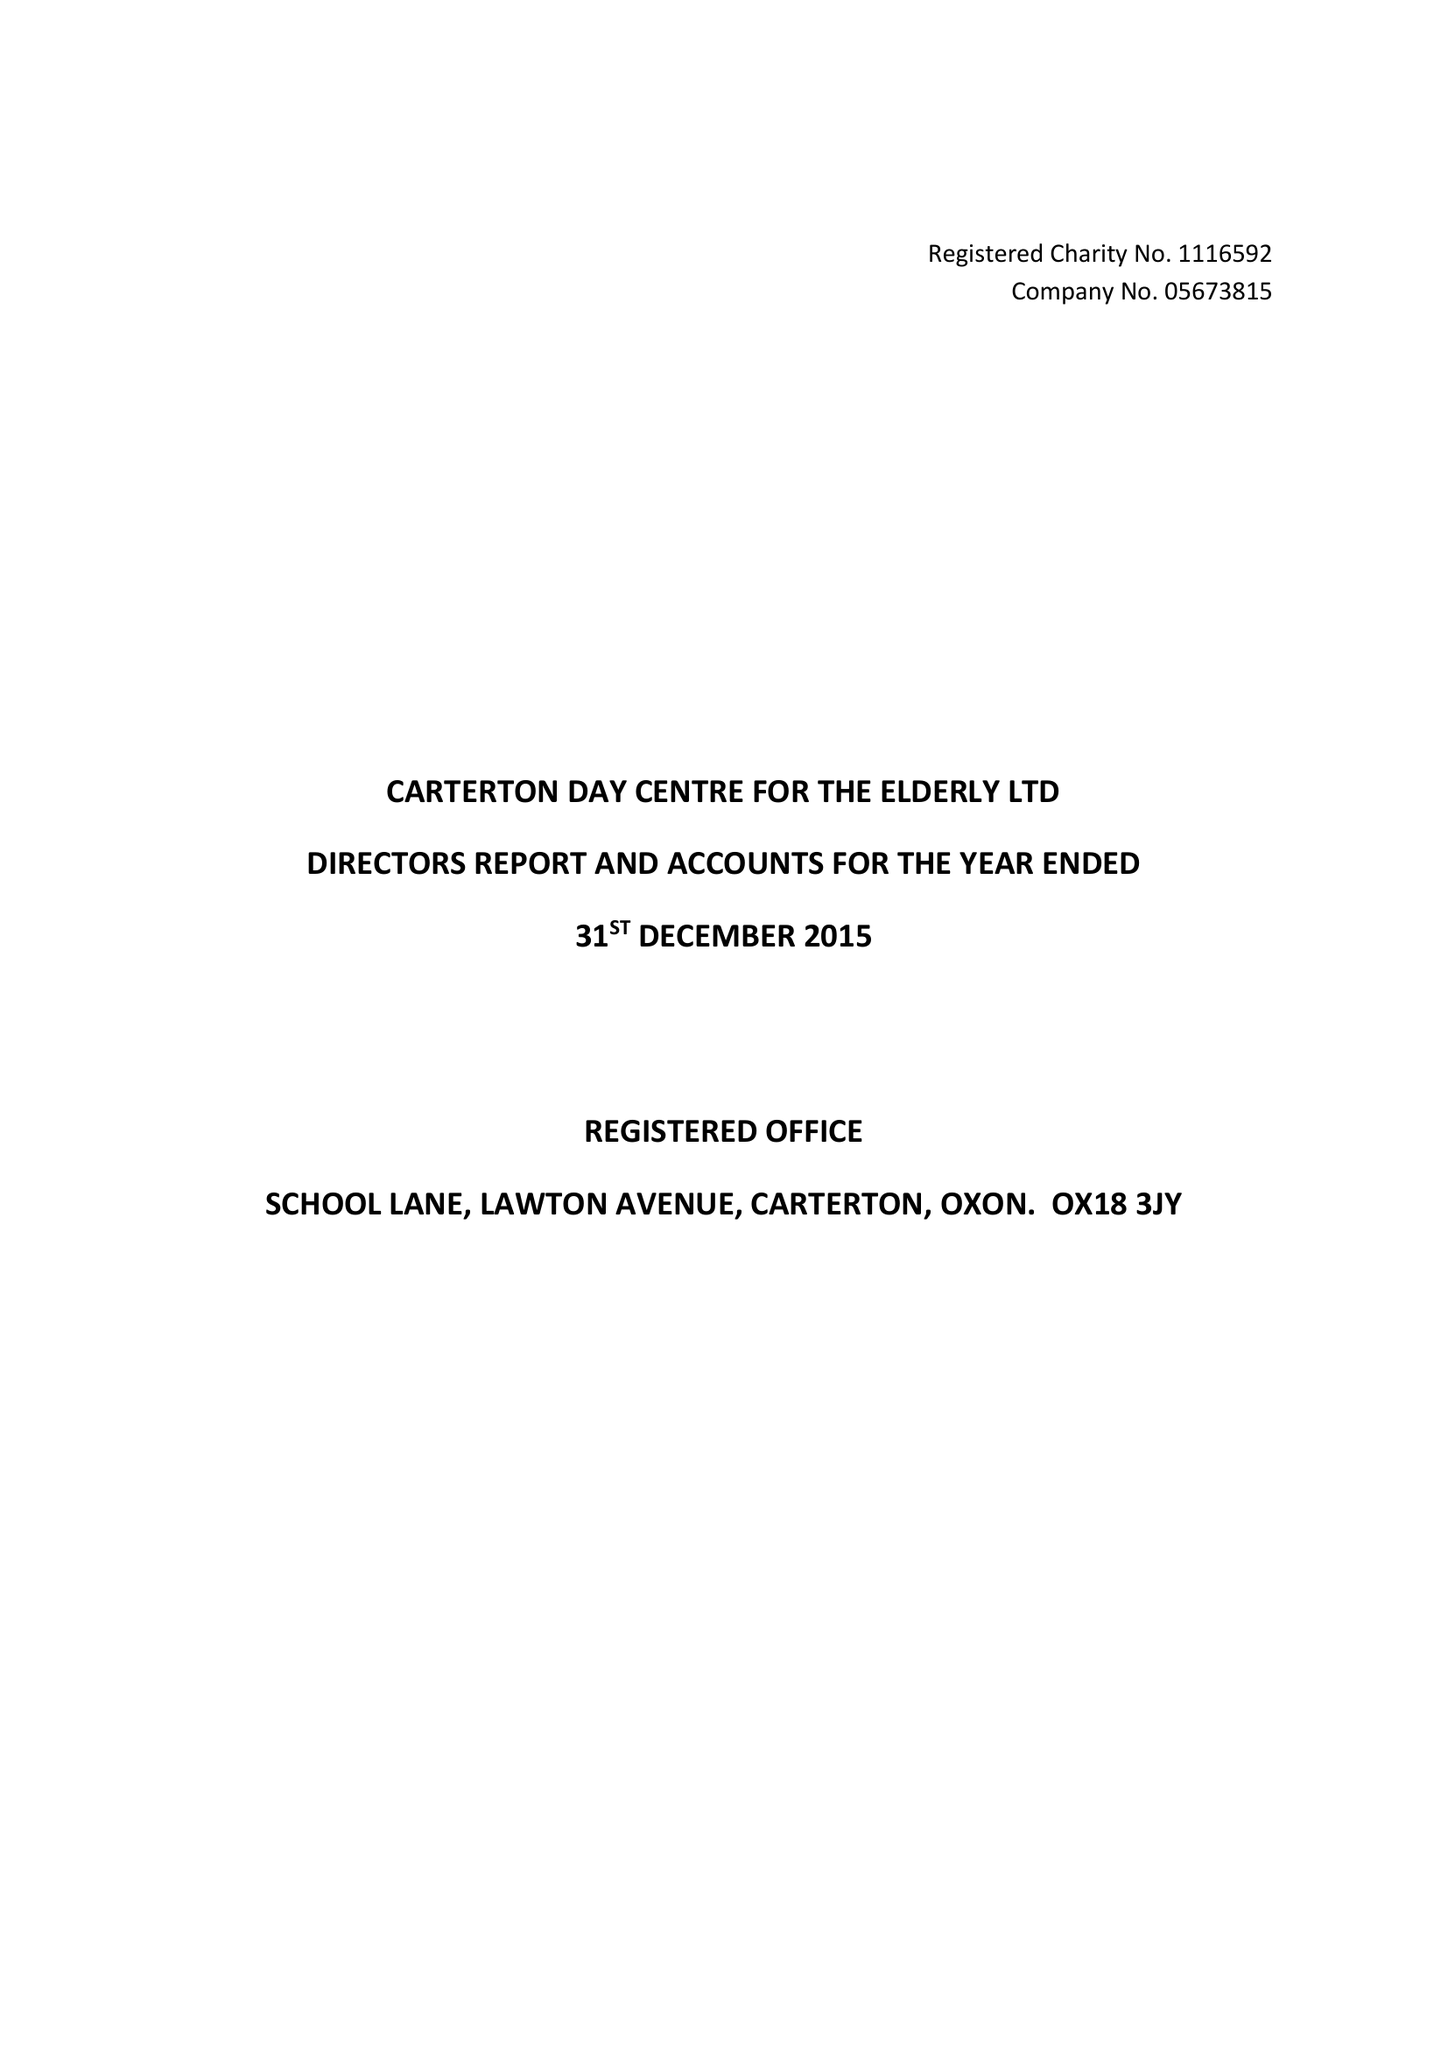What is the value for the spending_annually_in_british_pounds?
Answer the question using a single word or phrase. 34821.00 